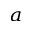Convert formula to latex. <formula><loc_0><loc_0><loc_500><loc_500>^ { a }</formula> 